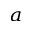Convert formula to latex. <formula><loc_0><loc_0><loc_500><loc_500>^ { a }</formula> 